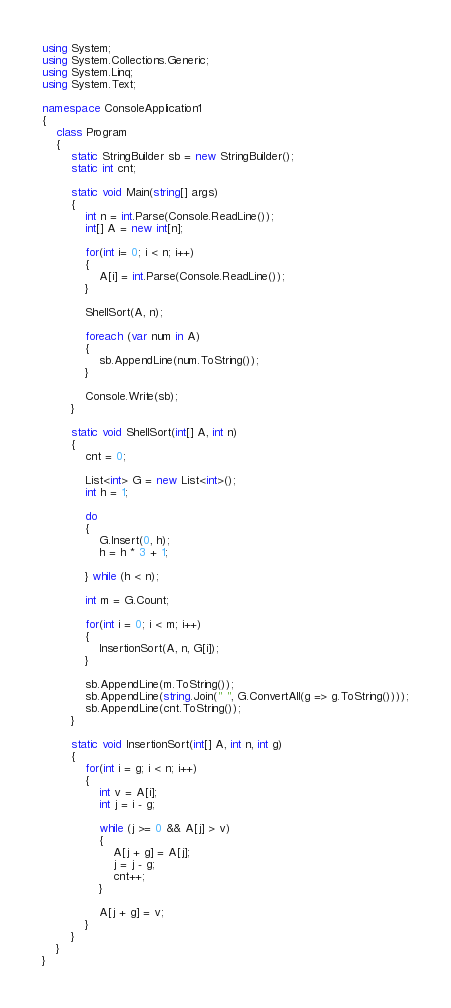Convert code to text. <code><loc_0><loc_0><loc_500><loc_500><_C#_>using System;
using System.Collections.Generic;
using System.Linq;
using System.Text;

namespace ConsoleApplication1
{
    class Program
    {
        static StringBuilder sb = new StringBuilder();
        static int cnt;

        static void Main(string[] args)
        {
            int n = int.Parse(Console.ReadLine());
            int[] A = new int[n];

            for(int i= 0; i < n; i++)
            {
                A[i] = int.Parse(Console.ReadLine());
            }

            ShellSort(A, n);

            foreach (var num in A)
            {
                sb.AppendLine(num.ToString());
            }

            Console.Write(sb);
        }

        static void ShellSort(int[] A, int n)
        {
            cnt = 0;

            List<int> G = new List<int>();
            int h = 1;

            do
            {
                G.Insert(0, h);
                h = h * 3 + 1;

            } while (h < n);

            int m = G.Count;

            for(int i = 0; i < m; i++)
            {
                InsertionSort(A, n, G[i]);
            }

            sb.AppendLine(m.ToString());
            sb.AppendLine(string.Join(" ", G.ConvertAll(g => g.ToString())));
            sb.AppendLine(cnt.ToString());
        }

        static void InsertionSort(int[] A, int n, int g)
        {
            for(int i = g; i < n; i++)
            {
                int v = A[i];
                int j = i - g;

                while (j >= 0 && A[j] > v)
                {
                    A[j + g] = A[j];
                    j = j - g;
                    cnt++;
                }

                A[j + g] = v;
            }
        }
    }
}</code> 